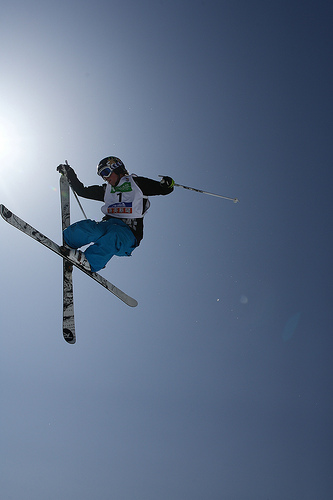Please extract the text content from this image. 1 